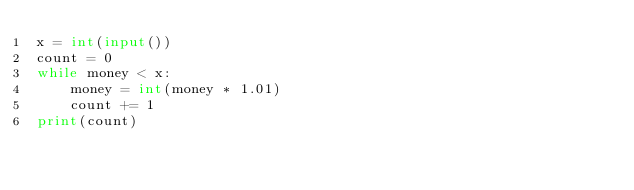Convert code to text. <code><loc_0><loc_0><loc_500><loc_500><_Python_>x = int(input())
count = 0
while money < x:
    money = int(money * 1.01)
    count += 1
print(count)
</code> 